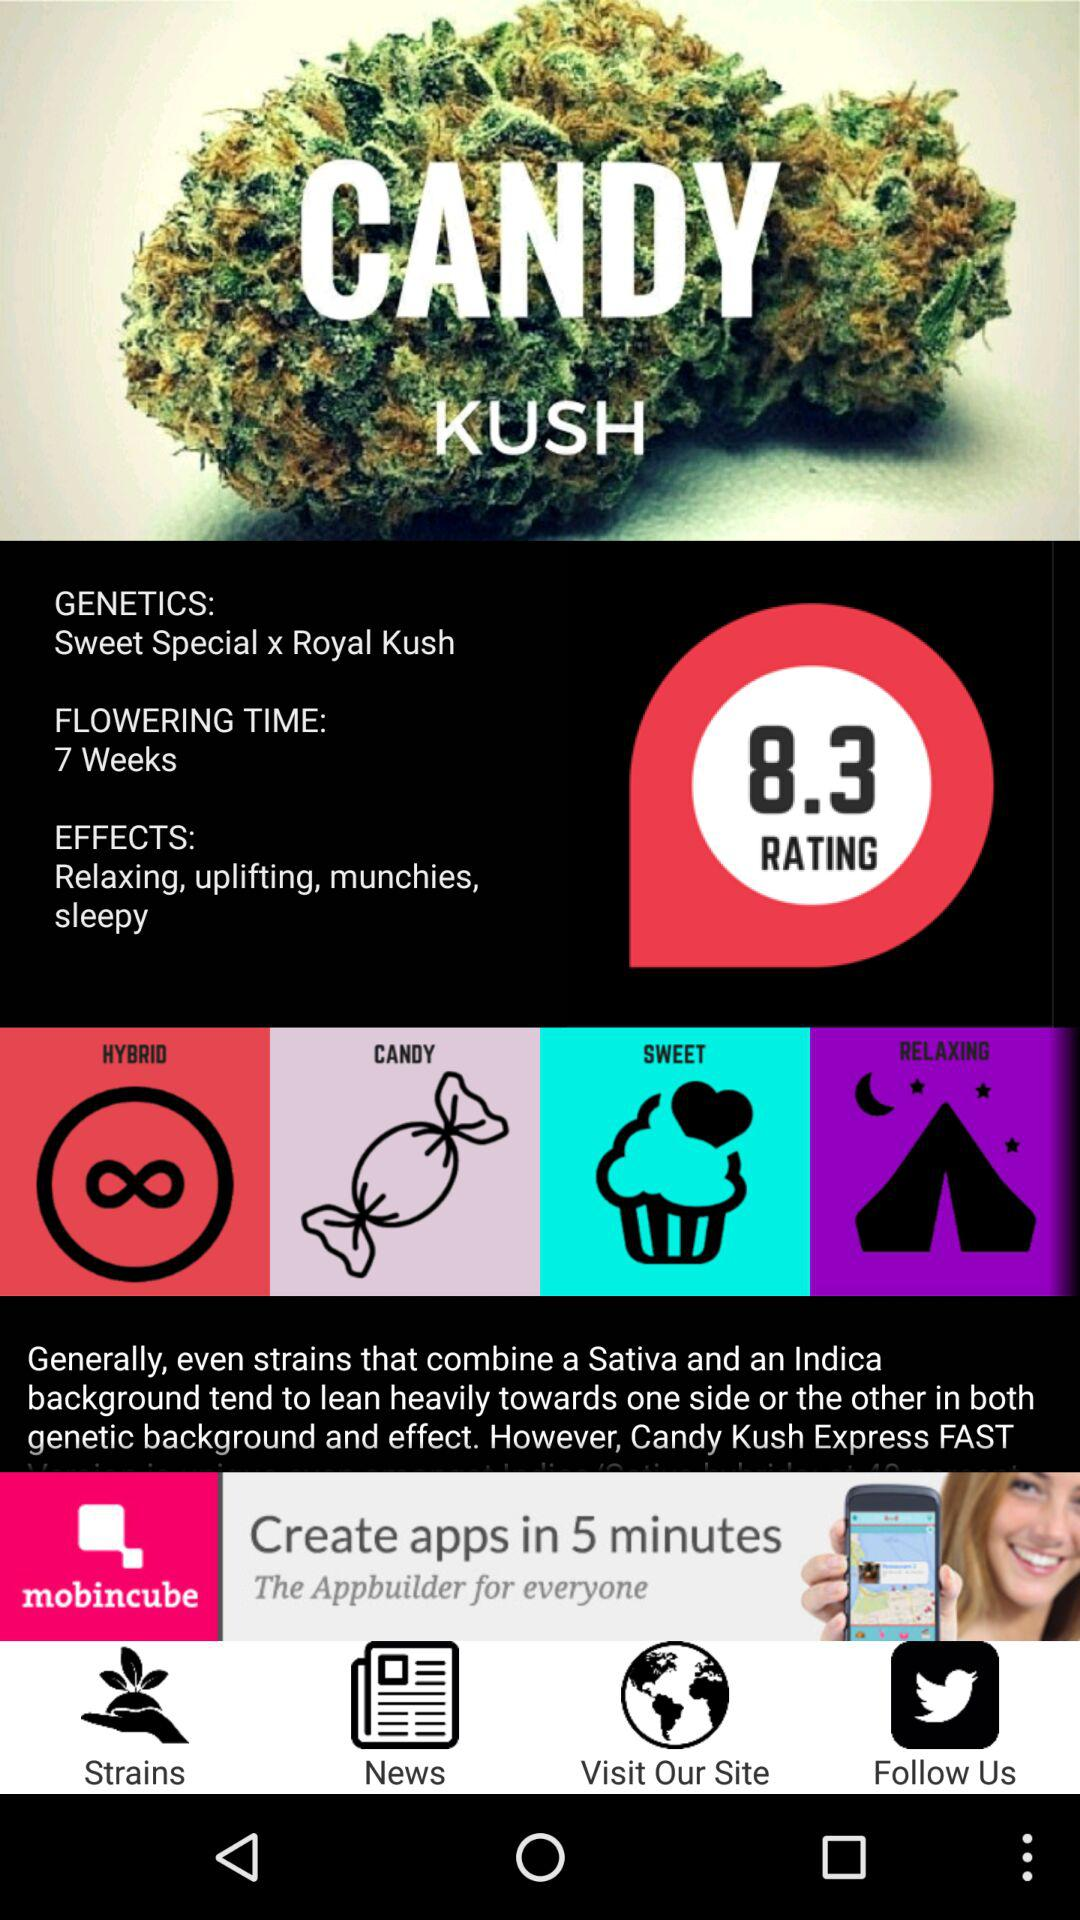How many effects does Candy Kush have?
Answer the question using a single word or phrase. 4 